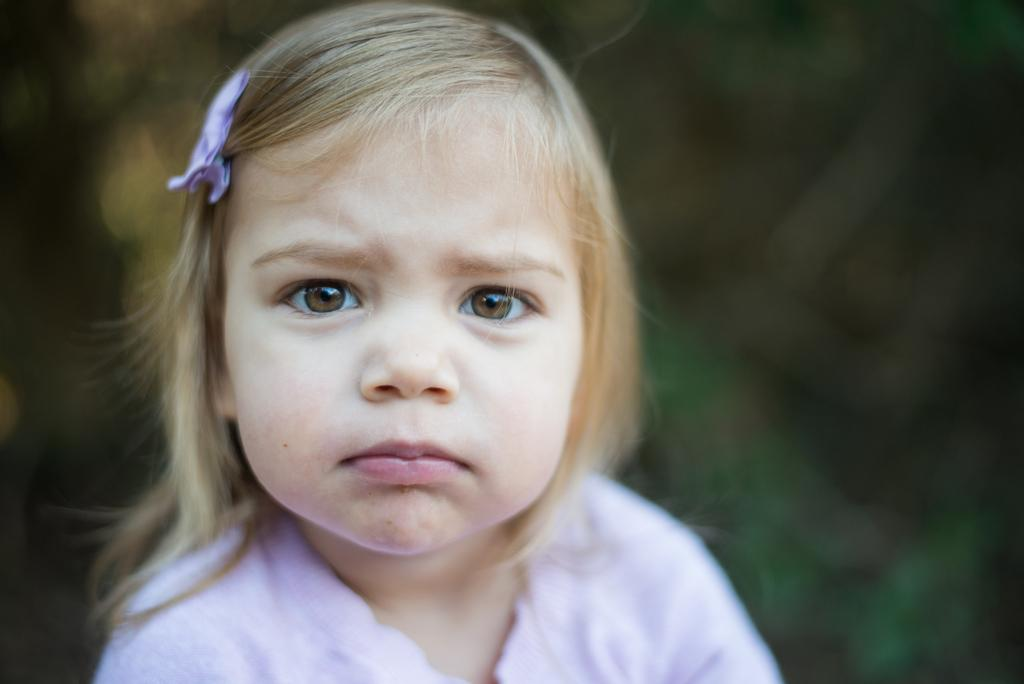What is the main subject of the image? There is a person in the image. What is the person wearing? The person is wearing a dress. Can you describe the background of the image? The background of the image is blurred. What is the person's opinion on digestion in the image? There is no information about the person's opinion on digestion in the image. What type of sweater is the person wearing in the image? The person is not wearing a sweater in the image; they are wearing a dress. 